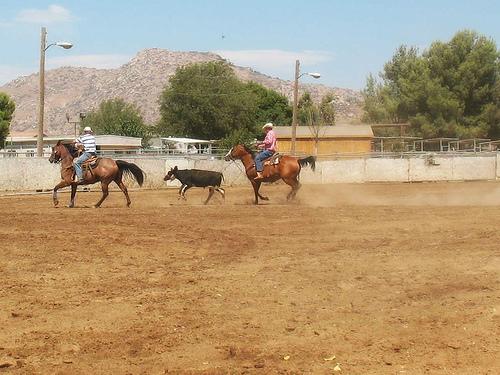How many people are wearing striped shirts?
Short answer required. 1. Is there snow on the hills?
Give a very brief answer. No. How many mammals are in this scene?
Concise answer only. 5. 